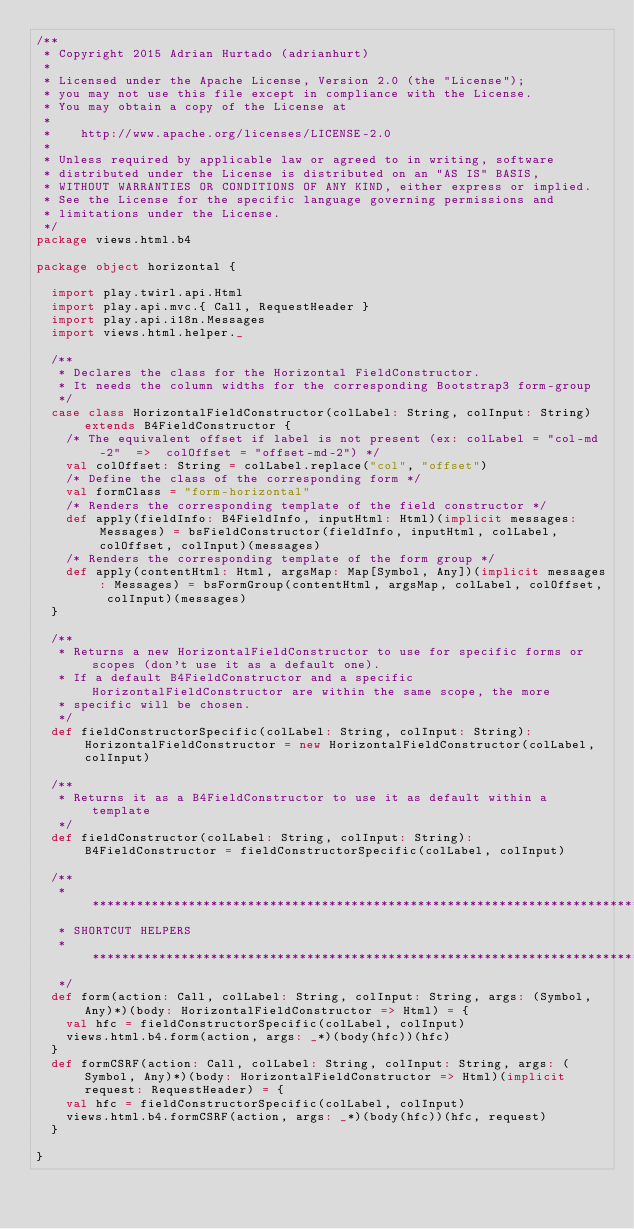Convert code to text. <code><loc_0><loc_0><loc_500><loc_500><_Scala_>/**
 * Copyright 2015 Adrian Hurtado (adrianhurt)
 *
 * Licensed under the Apache License, Version 2.0 (the "License");
 * you may not use this file except in compliance with the License.
 * You may obtain a copy of the License at
 *
 *    http://www.apache.org/licenses/LICENSE-2.0
 *
 * Unless required by applicable law or agreed to in writing, software
 * distributed under the License is distributed on an "AS IS" BASIS,
 * WITHOUT WARRANTIES OR CONDITIONS OF ANY KIND, either express or implied.
 * See the License for the specific language governing permissions and
 * limitations under the License.
 */
package views.html.b4

package object horizontal {

  import play.twirl.api.Html
  import play.api.mvc.{ Call, RequestHeader }
  import play.api.i18n.Messages
  import views.html.helper._

  /**
   * Declares the class for the Horizontal FieldConstructor.
   * It needs the column widths for the corresponding Bootstrap3 form-group
   */
  case class HorizontalFieldConstructor(colLabel: String, colInput: String) extends B4FieldConstructor {
    /* The equivalent offset if label is not present (ex: colLabel = "col-md-2"  =>  colOffset = "offset-md-2") */
    val colOffset: String = colLabel.replace("col", "offset")
    /* Define the class of the corresponding form */
    val formClass = "form-horizontal"
    /* Renders the corresponding template of the field constructor */
    def apply(fieldInfo: B4FieldInfo, inputHtml: Html)(implicit messages: Messages) = bsFieldConstructor(fieldInfo, inputHtml, colLabel, colOffset, colInput)(messages)
    /* Renders the corresponding template of the form group */
    def apply(contentHtml: Html, argsMap: Map[Symbol, Any])(implicit messages: Messages) = bsFormGroup(contentHtml, argsMap, colLabel, colOffset, colInput)(messages)
  }

  /**
   * Returns a new HorizontalFieldConstructor to use for specific forms or scopes (don't use it as a default one).
   * If a default B4FieldConstructor and a specific HorizontalFieldConstructor are within the same scope, the more
   * specific will be chosen.
   */
  def fieldConstructorSpecific(colLabel: String, colInput: String): HorizontalFieldConstructor = new HorizontalFieldConstructor(colLabel, colInput)

  /**
   * Returns it as a B4FieldConstructor to use it as default within a template
   */
  def fieldConstructor(colLabel: String, colInput: String): B4FieldConstructor = fieldConstructorSpecific(colLabel, colInput)

  /**
   * **********************************************************************************************************************************
   * SHORTCUT HELPERS
   * *********************************************************************************************************************************
   */
  def form(action: Call, colLabel: String, colInput: String, args: (Symbol, Any)*)(body: HorizontalFieldConstructor => Html) = {
    val hfc = fieldConstructorSpecific(colLabel, colInput)
    views.html.b4.form(action, args: _*)(body(hfc))(hfc)
  }
  def formCSRF(action: Call, colLabel: String, colInput: String, args: (Symbol, Any)*)(body: HorizontalFieldConstructor => Html)(implicit request: RequestHeader) = {
    val hfc = fieldConstructorSpecific(colLabel, colInput)
    views.html.b4.formCSRF(action, args: _*)(body(hfc))(hfc, request)
  }

}</code> 